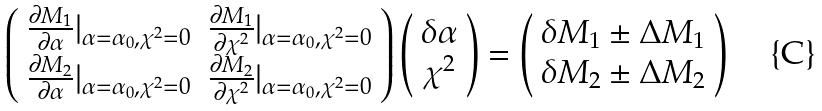Convert formula to latex. <formula><loc_0><loc_0><loc_500><loc_500>\left ( \begin{array} { c c } \frac { \partial M _ { 1 } } { \partial { \alpha } } | _ { \alpha = \alpha _ { 0 } , \chi ^ { 2 } = 0 } & \frac { \partial M _ { 1 } } { \partial { \chi ^ { 2 } } } | _ { \alpha = \alpha _ { 0 } , \chi ^ { 2 } = 0 } \\ \frac { \partial M _ { 2 } } { \partial { \alpha } } | _ { \alpha = \alpha _ { 0 } , \chi ^ { 2 } = 0 } & \frac { \partial M _ { 2 } } { \partial { \chi ^ { 2 } } } | _ { \alpha = \alpha _ { 0 } , \chi ^ { 2 } = 0 } \end{array} \right ) \left ( \begin{array} { c } \delta \alpha \\ \chi ^ { 2 } \end{array} \right ) = \left ( \begin{array} { c } \delta M _ { 1 } \pm \Delta M _ { 1 } \\ \delta M _ { 2 } \pm \Delta M _ { 2 } \end{array} \right )</formula> 